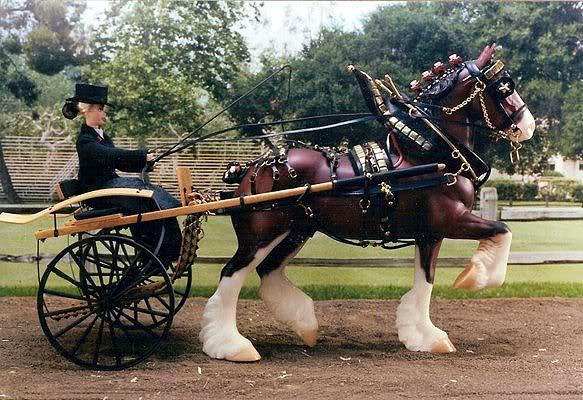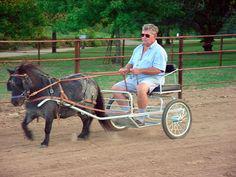The first image is the image on the left, the second image is the image on the right. Examine the images to the left and right. Is the description "There are more than two people being pulled by a horse." accurate? Answer yes or no. No. The first image is the image on the left, the second image is the image on the right. Given the left and right images, does the statement "Each image depicts one person sitting in a cart pulled by a single pony or horse." hold true? Answer yes or no. Yes. 